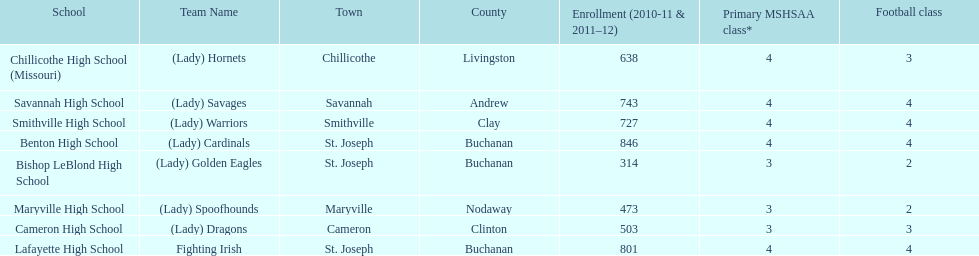How many of the schools had at least 500 students enrolled in the 2010-2011 and 2011-2012 season? 6. I'm looking to parse the entire table for insights. Could you assist me with that? {'header': ['School', 'Team Name', 'Town', 'County', 'Enrollment (2010-11 & 2011–12)', 'Primary MSHSAA class*', 'Football class'], 'rows': [['Chillicothe High School (Missouri)', '(Lady) Hornets', 'Chillicothe', 'Livingston', '638', '4', '3'], ['Savannah High School', '(Lady) Savages', 'Savannah', 'Andrew', '743', '4', '4'], ['Smithville High School', '(Lady) Warriors', 'Smithville', 'Clay', '727', '4', '4'], ['Benton High School', '(Lady) Cardinals', 'St. Joseph', 'Buchanan', '846', '4', '4'], ['Bishop LeBlond High School', '(Lady) Golden Eagles', 'St. Joseph', 'Buchanan', '314', '3', '2'], ['Maryville High School', '(Lady) Spoofhounds', 'Maryville', 'Nodaway', '473', '3', '2'], ['Cameron High School', '(Lady) Dragons', 'Cameron', 'Clinton', '503', '3', '3'], ['Lafayette High School', 'Fighting Irish', 'St. Joseph', 'Buchanan', '801', '4', '4']]} 